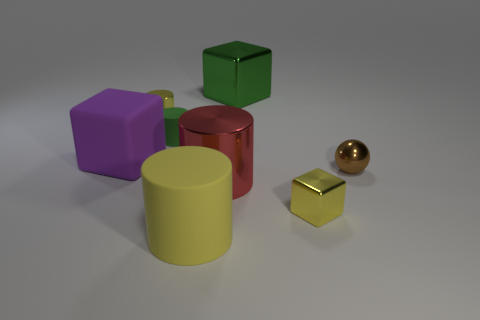Add 1 tiny purple metallic balls. How many objects exist? 9 Subtract all cubes. How many objects are left? 5 Add 6 small green objects. How many small green objects are left? 7 Add 4 shiny balls. How many shiny balls exist? 5 Subtract 0 brown cylinders. How many objects are left? 8 Subtract all tiny blue rubber cylinders. Subtract all large purple rubber cubes. How many objects are left? 7 